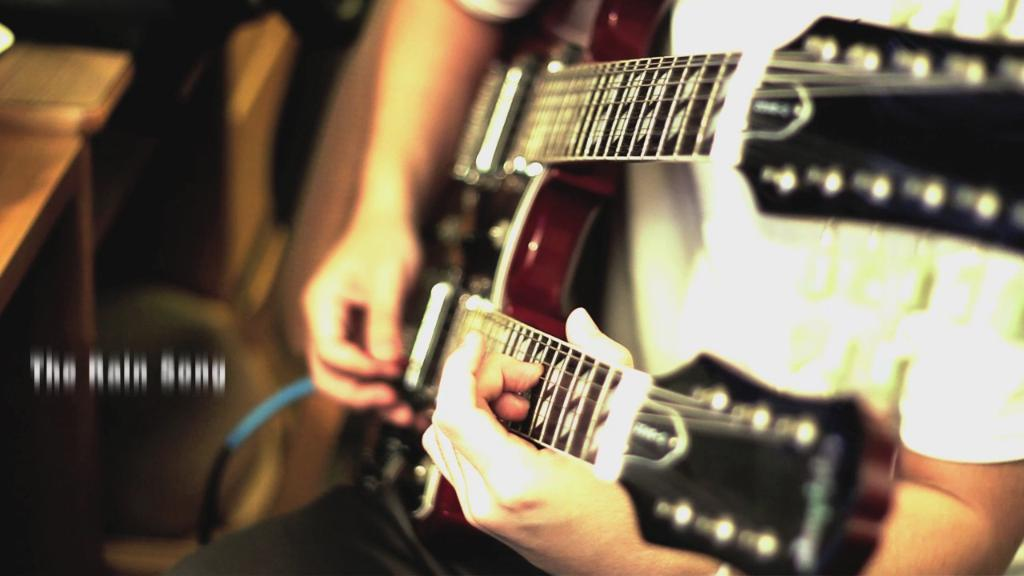What is the person in the image doing? The person is playing a guitar. What object can be seen in the image besides the person? There is a table in the image. Can you describe any additional features of the image? There is a watermark on the left side of the image. What type of dress is the person wearing in the image? There is no dress present in the image; the person is playing a guitar. Can you tell me how many stamps are on the watermark? There are no stamps present in the image; there is only a watermark on the left side. 